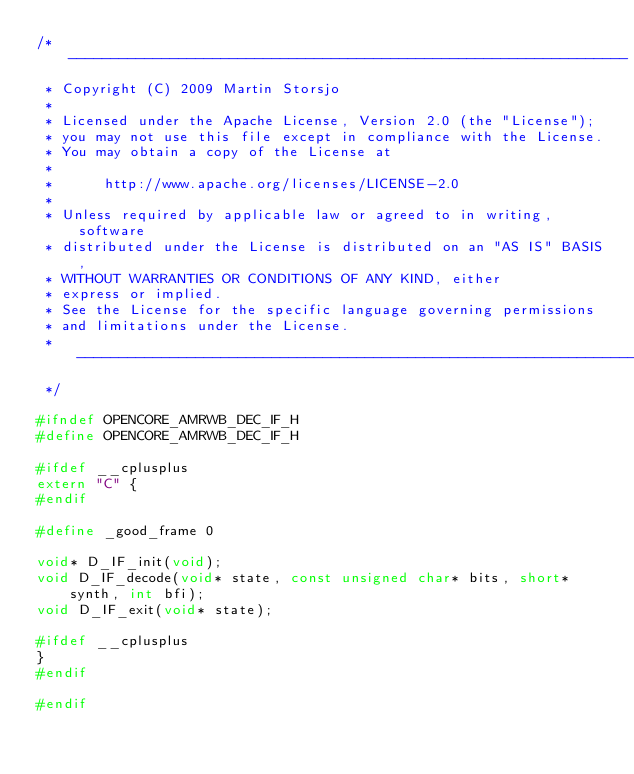<code> <loc_0><loc_0><loc_500><loc_500><_C_>/* ------------------------------------------------------------------
 * Copyright (C) 2009 Martin Storsjo
 *
 * Licensed under the Apache License, Version 2.0 (the "License");
 * you may not use this file except in compliance with the License.
 * You may obtain a copy of the License at
 *
 *      http://www.apache.org/licenses/LICENSE-2.0
 *
 * Unless required by applicable law or agreed to in writing, software
 * distributed under the License is distributed on an "AS IS" BASIS,
 * WITHOUT WARRANTIES OR CONDITIONS OF ANY KIND, either
 * express or implied.
 * See the License for the specific language governing permissions
 * and limitations under the License.
 * -------------------------------------------------------------------
 */

#ifndef OPENCORE_AMRWB_DEC_IF_H
#define OPENCORE_AMRWB_DEC_IF_H

#ifdef __cplusplus
extern "C" {
#endif

#define _good_frame 0

void* D_IF_init(void);
void D_IF_decode(void* state, const unsigned char* bits, short* synth, int bfi);
void D_IF_exit(void* state);

#ifdef __cplusplus
}
#endif

#endif
</code> 